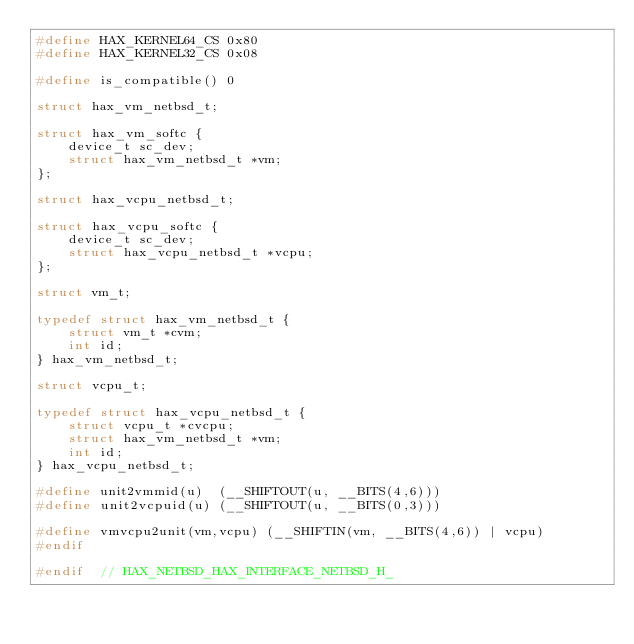<code> <loc_0><loc_0><loc_500><loc_500><_C_>#define HAX_KERNEL64_CS 0x80
#define HAX_KERNEL32_CS 0x08

#define is_compatible() 0

struct hax_vm_netbsd_t;

struct hax_vm_softc {
    device_t sc_dev;
    struct hax_vm_netbsd_t *vm;
};

struct hax_vcpu_netbsd_t;

struct hax_vcpu_softc {
    device_t sc_dev;
    struct hax_vcpu_netbsd_t *vcpu;
};

struct vm_t;

typedef struct hax_vm_netbsd_t {
    struct vm_t *cvm;
    int id;
} hax_vm_netbsd_t;

struct vcpu_t;

typedef struct hax_vcpu_netbsd_t {
    struct vcpu_t *cvcpu;
    struct hax_vm_netbsd_t *vm;
    int id;
} hax_vcpu_netbsd_t;

#define unit2vmmid(u)  (__SHIFTOUT(u, __BITS(4,6)))
#define unit2vcpuid(u) (__SHIFTOUT(u, __BITS(0,3)))

#define vmvcpu2unit(vm,vcpu) (__SHIFTIN(vm, __BITS(4,6)) | vcpu)
#endif

#endif  // HAX_NETBSD_HAX_INTERFACE_NETBSD_H_
</code> 